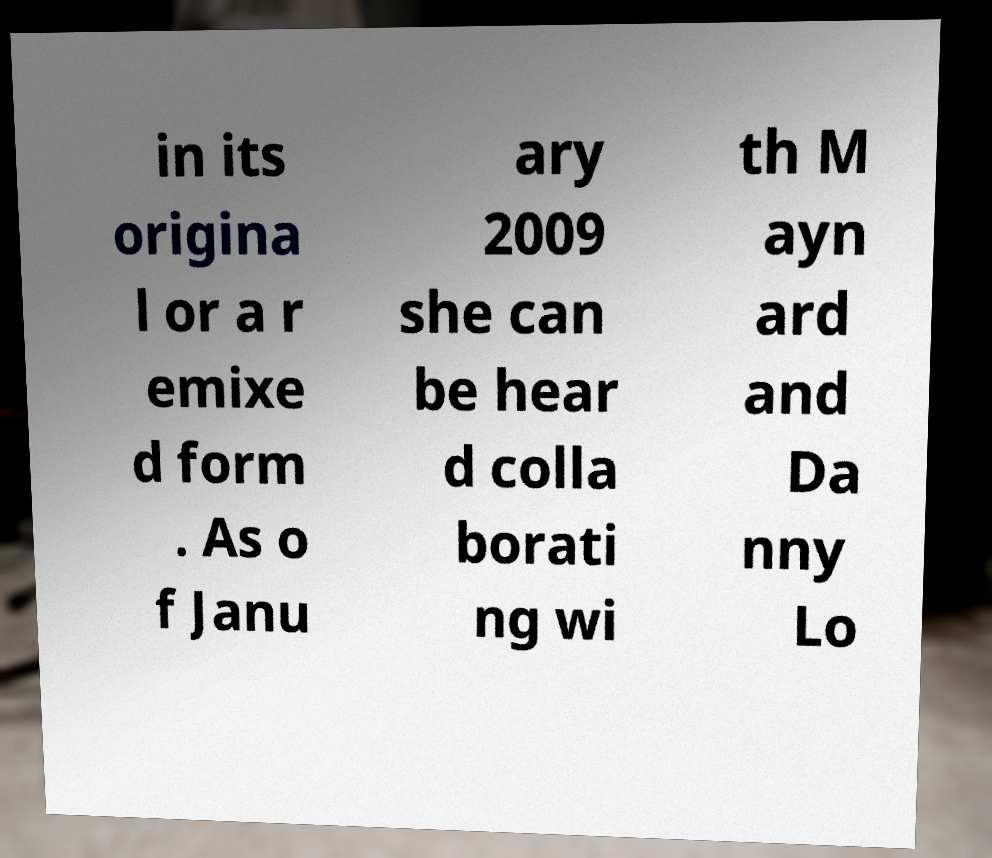Can you accurately transcribe the text from the provided image for me? in its origina l or a r emixe d form . As o f Janu ary 2009 she can be hear d colla borati ng wi th M ayn ard and Da nny Lo 